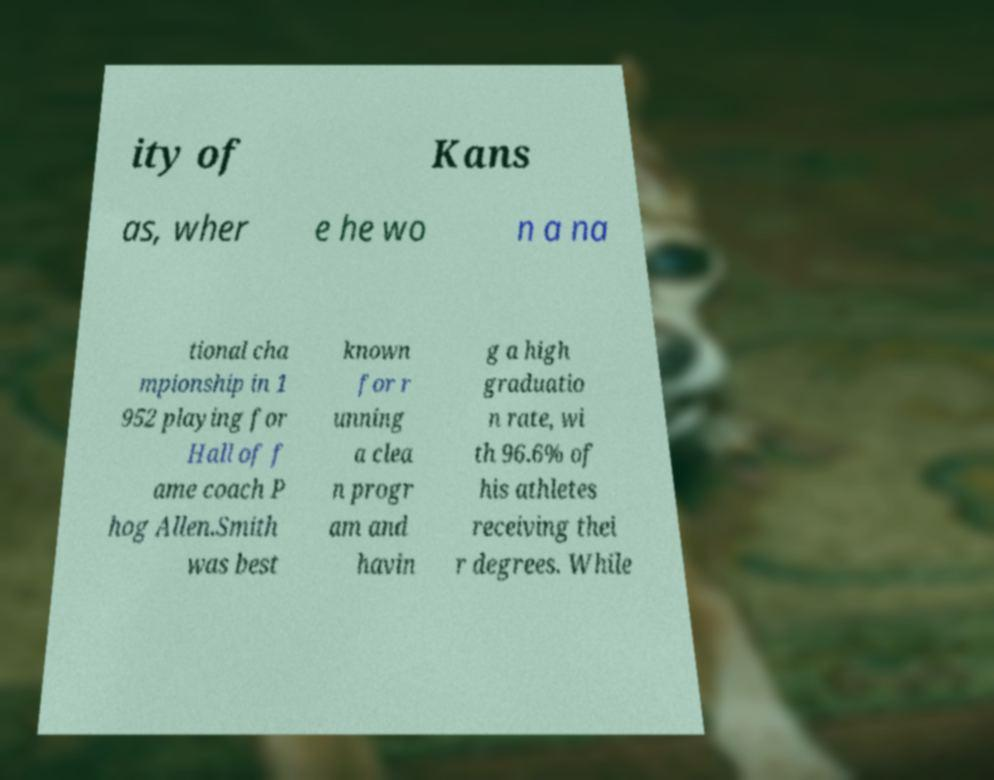Could you extract and type out the text from this image? ity of Kans as, wher e he wo n a na tional cha mpionship in 1 952 playing for Hall of f ame coach P hog Allen.Smith was best known for r unning a clea n progr am and havin g a high graduatio n rate, wi th 96.6% of his athletes receiving thei r degrees. While 